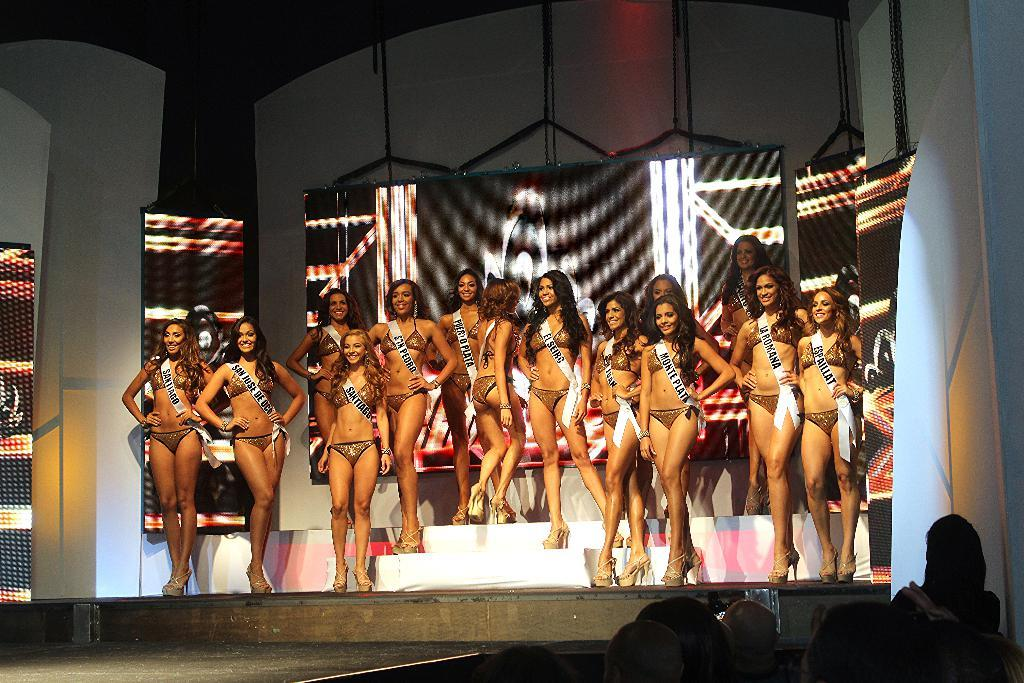What is happening on the stage in the image? There are women standing on the stage in the image. What is the facial expression of the women on the stage? The women are smiling. What can be seen in the background of the image? There is a screen in the background of the image. What type of party is being celebrated on the stage in the image? There is no indication of a party in the image; it simply shows women standing on the stage with smiling expressions. 